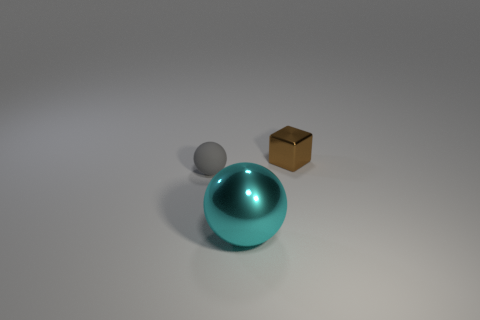Are there fewer tiny brown shiny cubes in front of the tiny matte sphere than brown metallic things?
Offer a very short reply. Yes. How many tiny metal objects are the same color as the tiny block?
Provide a succinct answer. 0. What is the size of the shiny object in front of the tiny cube?
Your answer should be very brief. Large. The small thing to the right of the ball on the right side of the small thing that is left of the tiny brown thing is what shape?
Provide a short and direct response. Cube. What shape is the object that is to the left of the brown block and behind the big ball?
Keep it short and to the point. Sphere. Is there a gray rubber thing that has the same size as the gray sphere?
Provide a short and direct response. No. Does the object that is right of the large cyan ball have the same shape as the gray object?
Keep it short and to the point. No. Is the brown thing the same shape as the small gray thing?
Provide a short and direct response. No. Is there another small rubber object that has the same shape as the small gray matte thing?
Your answer should be compact. No. What shape is the metallic object in front of the gray rubber sphere behind the large metal sphere?
Your response must be concise. Sphere. 